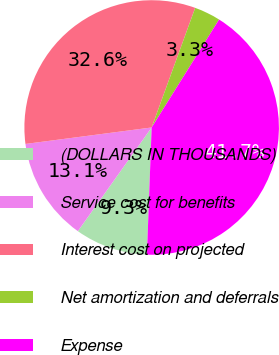<chart> <loc_0><loc_0><loc_500><loc_500><pie_chart><fcel>(DOLLARS IN THOUSANDS)<fcel>Service cost for benefits<fcel>Interest cost on projected<fcel>Net amortization and deferrals<fcel>Expense<nl><fcel>9.25%<fcel>13.09%<fcel>32.62%<fcel>3.33%<fcel>41.7%<nl></chart> 